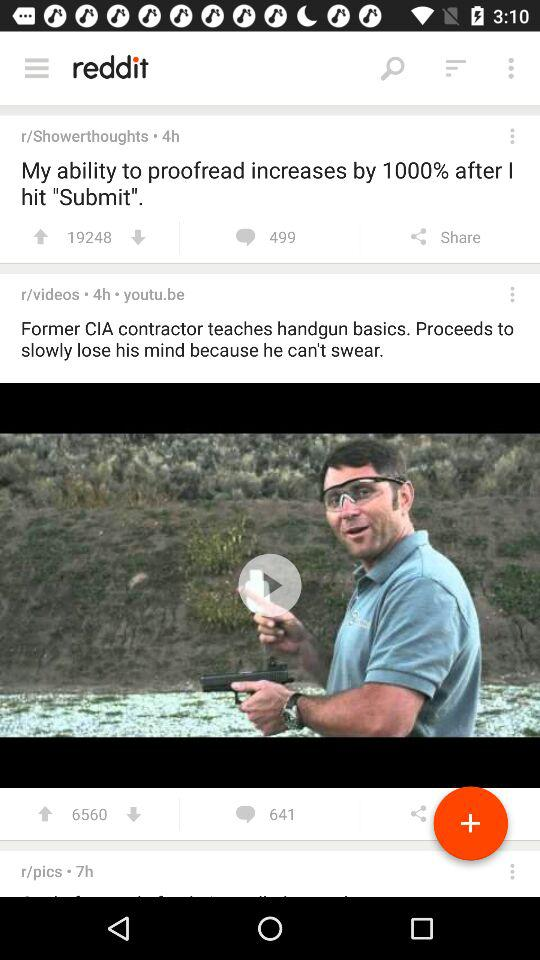How many hours ago was the post "Former CIA" updated? The post "Former CIA" was updated 4 hours ago. 